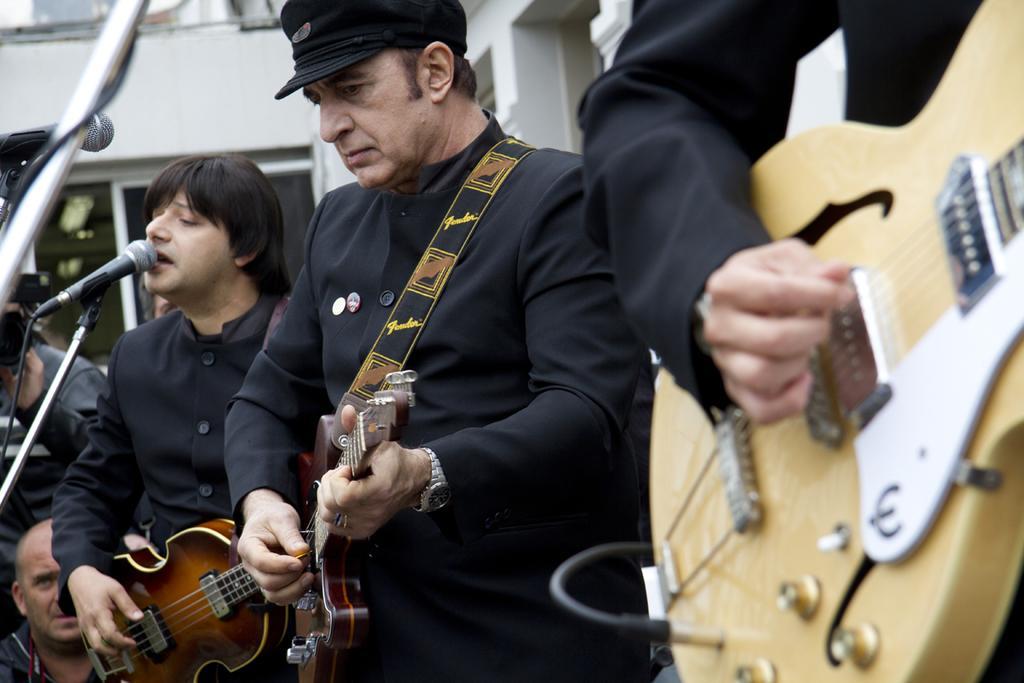Could you give a brief overview of what you see in this image? In this picture we can see three persons are playing guitars, there are two microphones on the left side, a person in the background is holding a camera, we can also see a building in the background. 